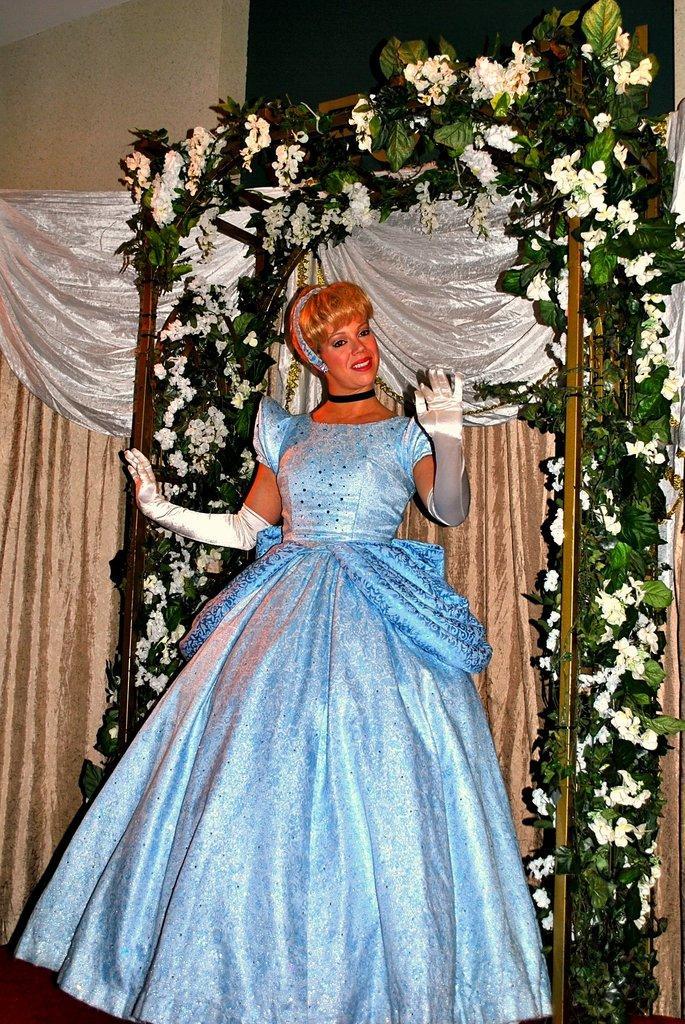Describe this image in one or two sentences. In this image there is a girl standing. She is wearing a frock. There are gloves to her hand. Behind her there is a metal rod. There are leaves and flowers to the road. Behind her there are curtains to the wall. 